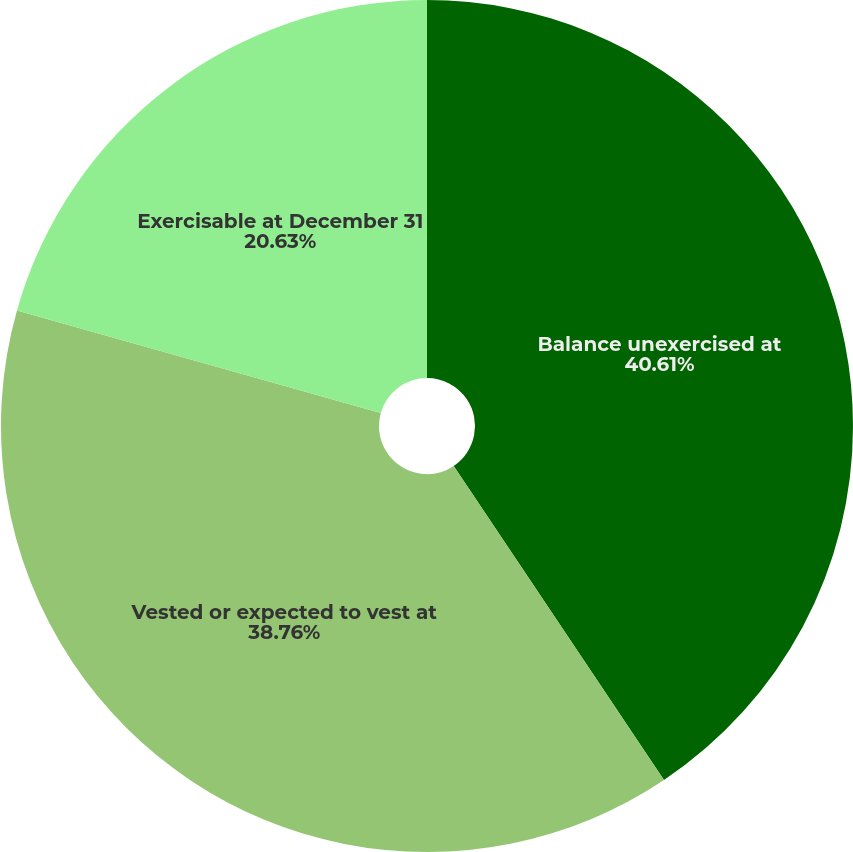Convert chart to OTSL. <chart><loc_0><loc_0><loc_500><loc_500><pie_chart><fcel>Balance unexercised at<fcel>Vested or expected to vest at<fcel>Exercisable at December 31<nl><fcel>40.61%<fcel>38.76%<fcel>20.63%<nl></chart> 